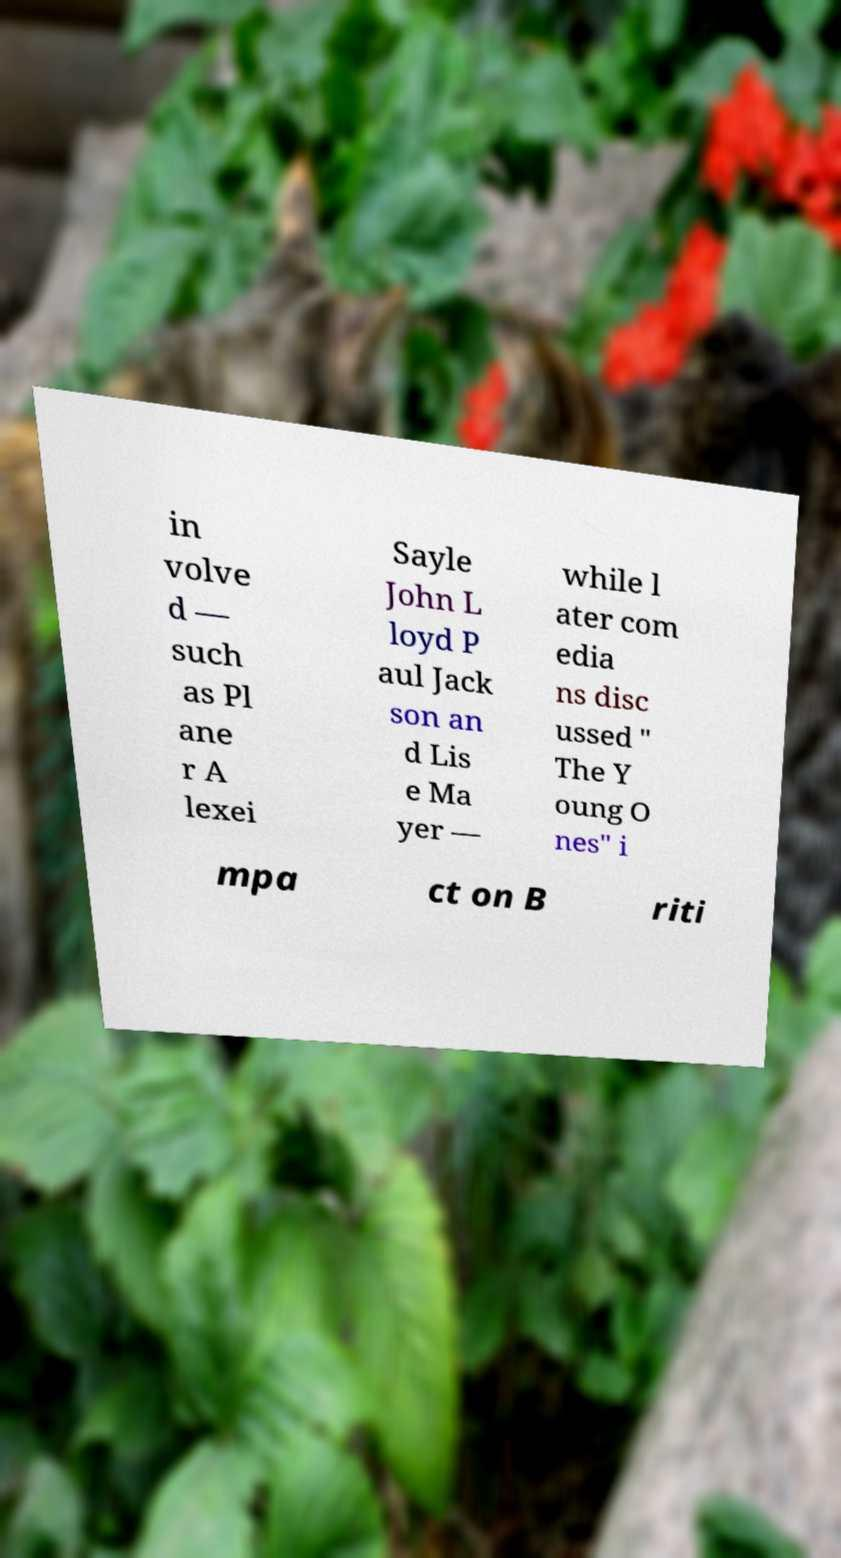For documentation purposes, I need the text within this image transcribed. Could you provide that? in volve d — such as Pl ane r A lexei Sayle John L loyd P aul Jack son an d Lis e Ma yer — while l ater com edia ns disc ussed " The Y oung O nes" i mpa ct on B riti 